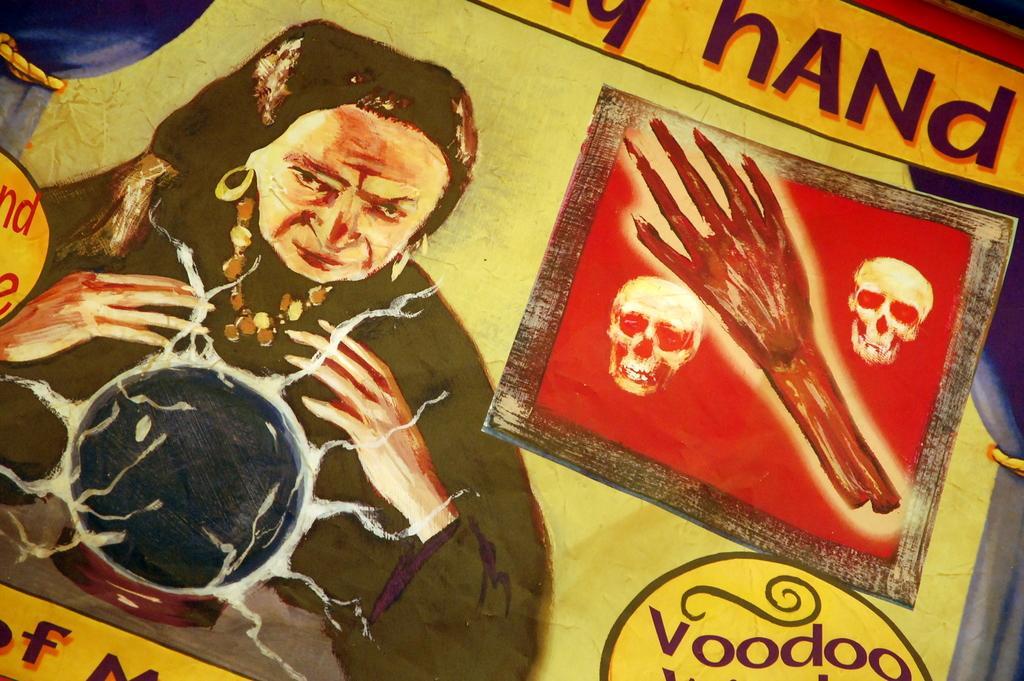Can you describe this image briefly? This image is a painting. On the right side we can see text and a human hand and skulls. On the left side of the image there is a woman. 